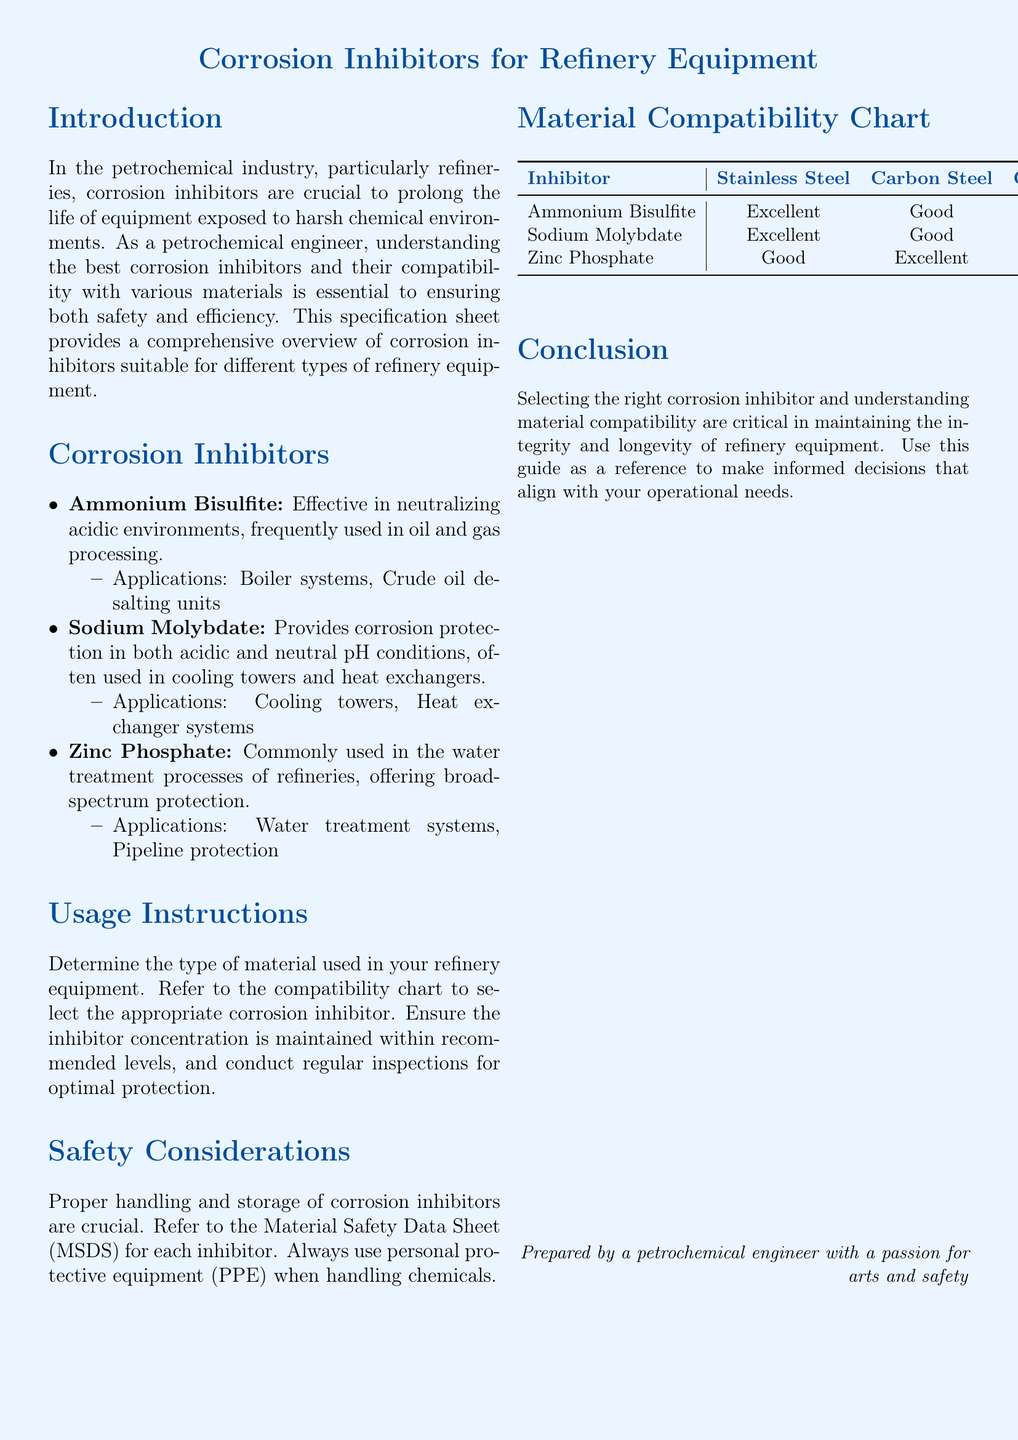what is the title of the document? The title is prominently displayed at the top of the document and is centered.
Answer: Corrosion Inhibitors for Refinery Equipment which corrosion inhibitor is effective in neutralizing acidic environments? The text lists Ammonium Bisulfite as the inhibitor effective in acidic environments.
Answer: Ammonium Bisulfite what application is Sodium Molybdate commonly used in? The document states it is used in cooling towers and heat exchangers.
Answer: Cooling towers, Heat exchanger systems which material has a compatibility rating of "Fair" with Sodium Molybdate? The Material Compatibility Chart indicates Copper Alloys have a compatibility rating of "Fair".
Answer: Copper Alloys how many corrosion inhibitors are listed in the document? The document lists three specific corrosion inhibitors.
Answer: Three what is the safety consideration mentioned for handling corrosion inhibitors? The text advises referring to the Material Safety Data Sheet and using personal protective equipment.
Answer: Use personal protective equipment which inhibitor shows "Poor" compatibility with Copper Alloys? Reference to the Material Compatibility Chart shows Ammonium Bisulfite as having "Poor" compatibility.
Answer: Ammonium Bisulfite is Zinc Phosphate compatible with Aluminum? The compatibility rating for Aluminum is listed as N/A, indicating it is not applicable.
Answer: N/A 